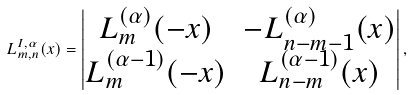<formula> <loc_0><loc_0><loc_500><loc_500>L _ { m , n } ^ { I , \alpha } ( x ) = \begin{vmatrix} L _ { m } ^ { ( \alpha ) } ( - x ) & - L _ { n - m - 1 } ^ { ( \alpha ) } ( x ) \\ L _ { m } ^ { ( \alpha - 1 ) } ( - x ) & L _ { n - m } ^ { ( \alpha - 1 ) } ( x ) \end{vmatrix} ,</formula> 